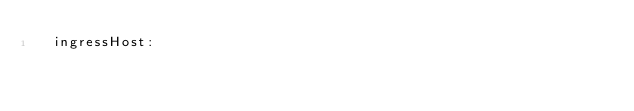<code> <loc_0><loc_0><loc_500><loc_500><_YAML_>  ingressHost: 
</code> 